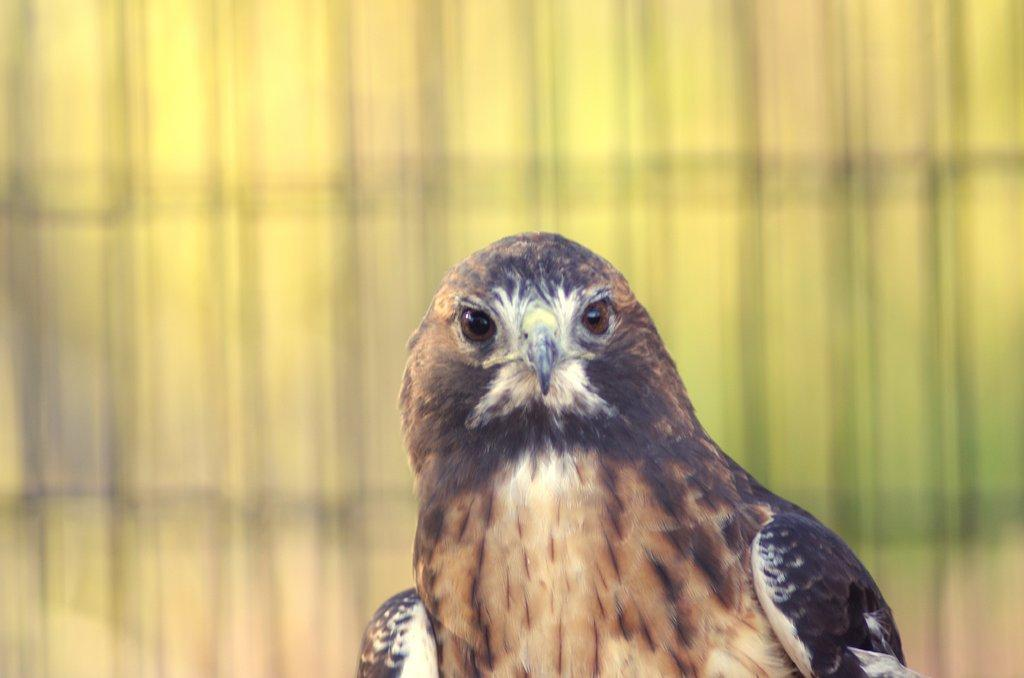What is located at the bottom of the image? There is a bird at the bottom of the image. Can you describe the background of the image? The background of the image is blurred. How many visitors can be seen in the image? There is no mention of visitors in the image, as it only features a bird at the bottom and a blurred background. 